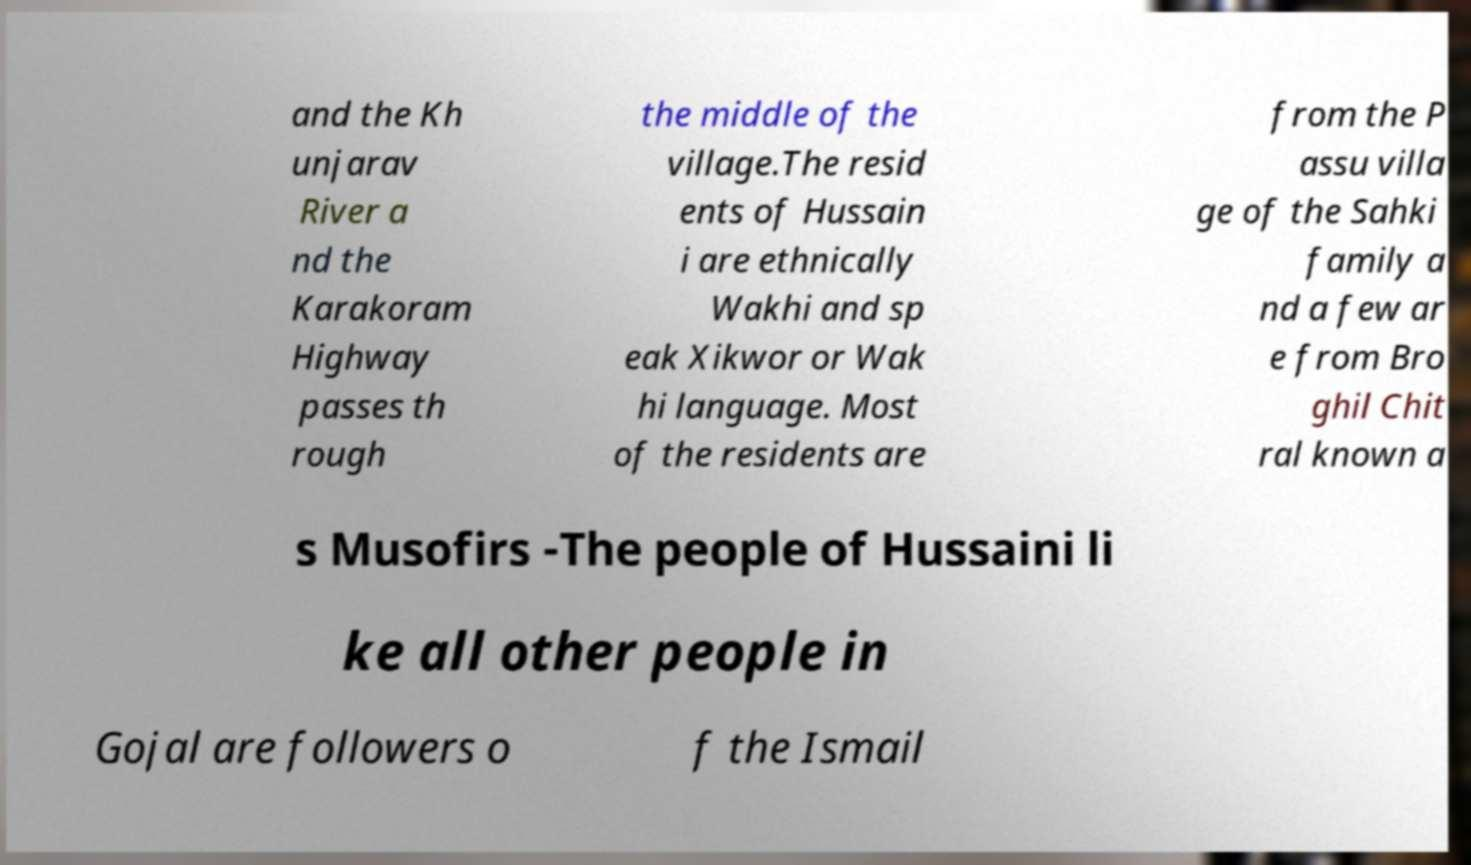Can you accurately transcribe the text from the provided image for me? and the Kh unjarav River a nd the Karakoram Highway passes th rough the middle of the village.The resid ents of Hussain i are ethnically Wakhi and sp eak Xikwor or Wak hi language. Most of the residents are from the P assu villa ge of the Sahki family a nd a few ar e from Bro ghil Chit ral known a s Musofirs -The people of Hussaini li ke all other people in Gojal are followers o f the Ismail 